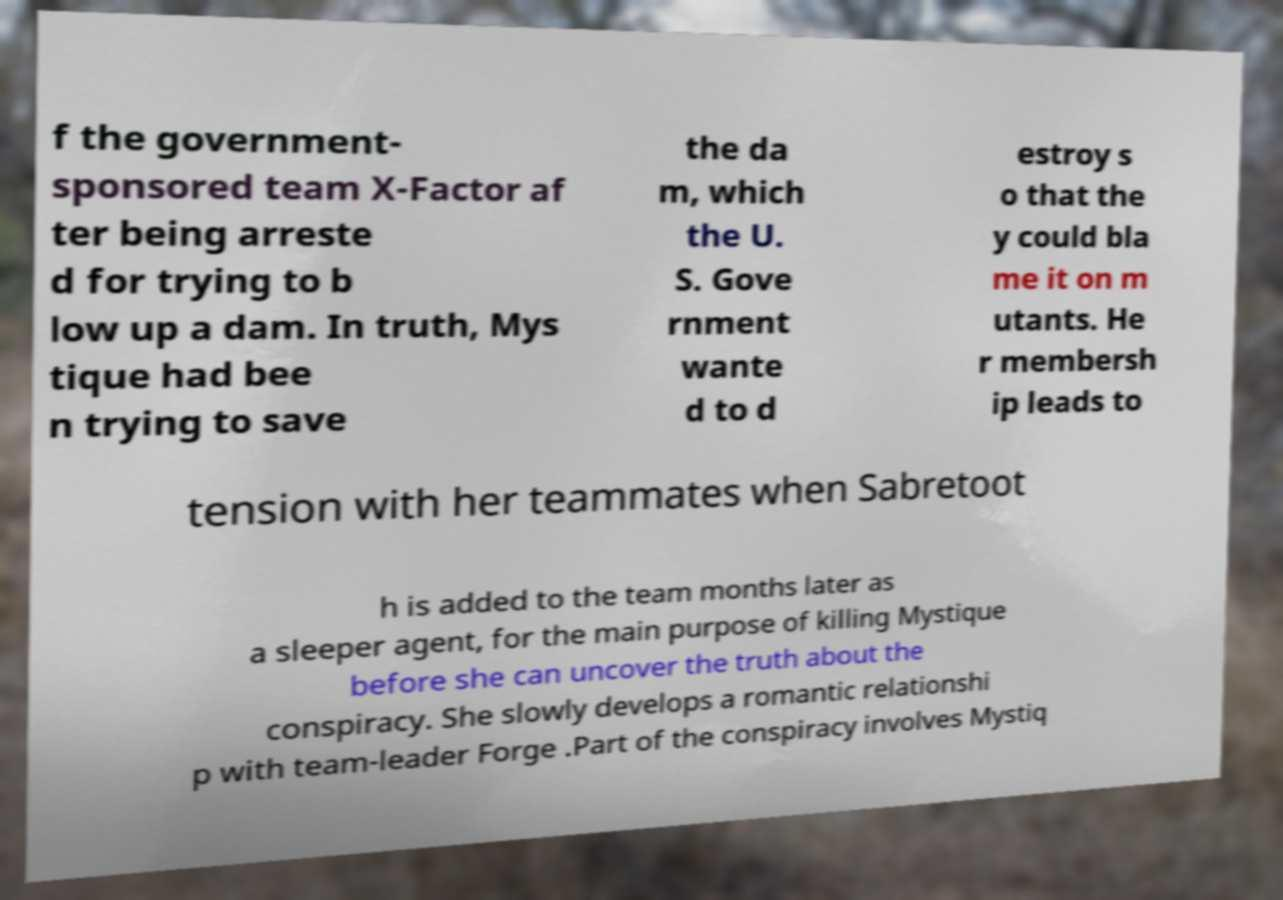For documentation purposes, I need the text within this image transcribed. Could you provide that? f the government- sponsored team X-Factor af ter being arreste d for trying to b low up a dam. In truth, Mys tique had bee n trying to save the da m, which the U. S. Gove rnment wante d to d estroy s o that the y could bla me it on m utants. He r membersh ip leads to tension with her teammates when Sabretoot h is added to the team months later as a sleeper agent, for the main purpose of killing Mystique before she can uncover the truth about the conspiracy. She slowly develops a romantic relationshi p with team-leader Forge .Part of the conspiracy involves Mystiq 